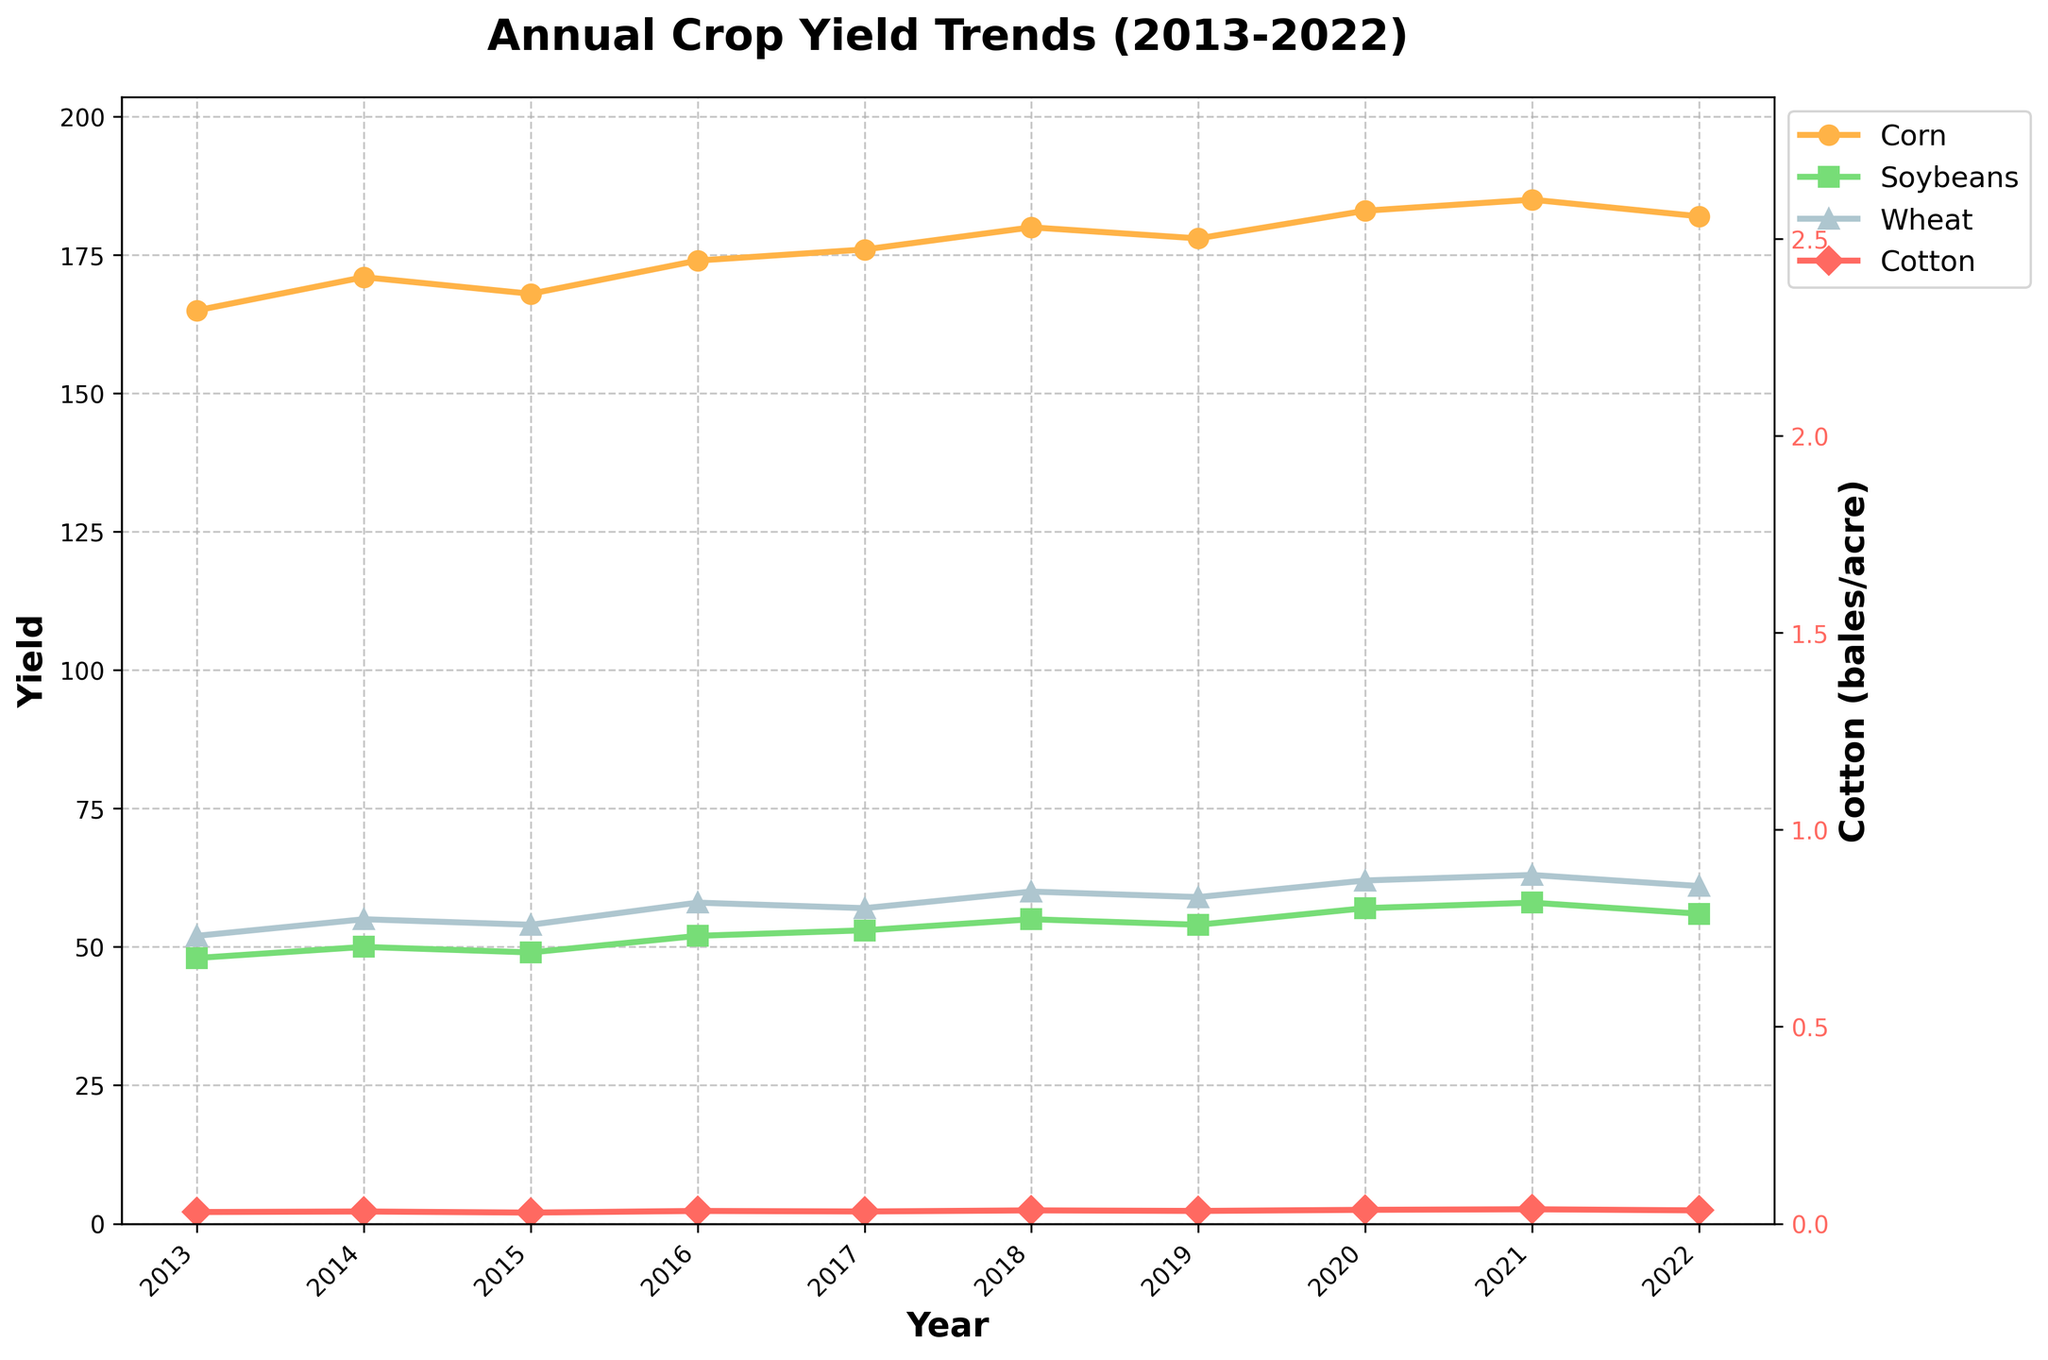What's the trend for corn yields over the last decade? Observing the line for corn, it starts at 165 bushels/acre in 2013 and generally increases to 183 bushels/acre in 2020, then drops slightly to 182 bushels/acre in 2022. This shows a general upward trend.
Answer: Upwards Between 2017 and 2020, which crop showed the most consistent yield increase year-over-year? Comparing the slopes of the lines for different crops from 2017 to 2020, soybeans have a steady increase each year without any drop.
Answer: Soybeans How does the 2022 yield of wheat compare to its 2013 yield? Wheat yield increased from 52 bushels/acre in 2013 to 61 bushels/acre in 2022.
Answer: Increased What's the average yield of cotton over the decade? Adding all the yields of cotton from 2013 to 2022 and dividing by the number of years (10): (2.1+2.2+2.0+2.3+2.2+2.4+2.3+2.5+2.6+2.4)/10 = 2.3 bales/acre
Answer: 2.3 Which crop had the maximum recorded yield and in which year? Observing all the yields for all crops, wheat had the highest yield of 63 bushels/acre in 2021.
Answer: Wheat in 2021 During which year did cotton yield drop the most compared to the previous year? Observing the lines for cotton, the biggest drop is from 2014 (2.2 bales/acre) to 2015 (2.0 bales/acre), a drop of 0.2.
Answer: 2015 By how much did the soybean yield increase from 2015 to 2021? Soybean yields in 2015 were 49 bushels/acre and increased to 58 bushels/acre in 2021; the increase is 58 - 49 = 9 bushels/acre.
Answer: 9 bushels/acre Compare the 2020 yield of corn to the 2022 yield. The corn yield in 2020 was 183 bushels/acre and decreased slightly to 182 bushels/acre in 2022.
Answer: Slight decrease What's the overall range of yields for wheat observed in the last decade? The range is calculated by subtracting the minimum yield (52 bushels/acre in 2013) from the maximum yield (63 bushels/acre in 2021): 63 - 52 = 11 bushels/acre.
Answer: 11 bushels/acre What color represents wheat yields in the chart? Looking at the visual attributes, the color associated with wheat is a light blue-grayish tone.
Answer: Light blue-gray 